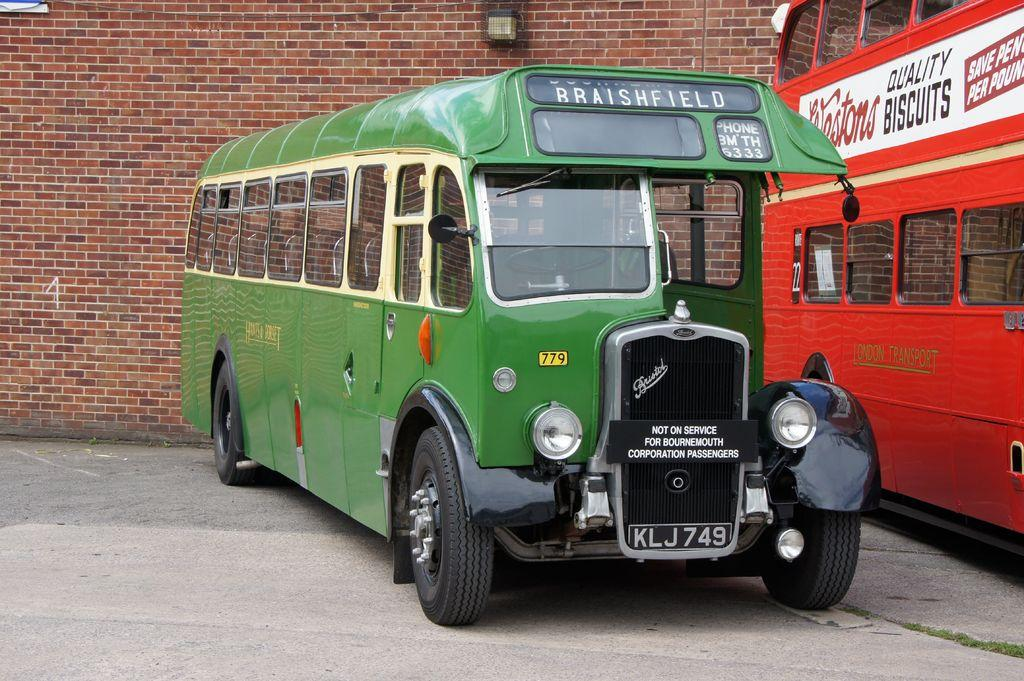How many vehicles can be seen in the image? There are two vehicles parked in the image. What is the background behind the vehicles? There is a wall with red bricks behind the vehicles. Can you describe any additional objects on the wall? There is an object hanging on the wall. What is the smell like in the image? The image does not provide any information about the smell, as it is a visual medium. 